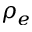Convert formula to latex. <formula><loc_0><loc_0><loc_500><loc_500>\rho _ { e }</formula> 